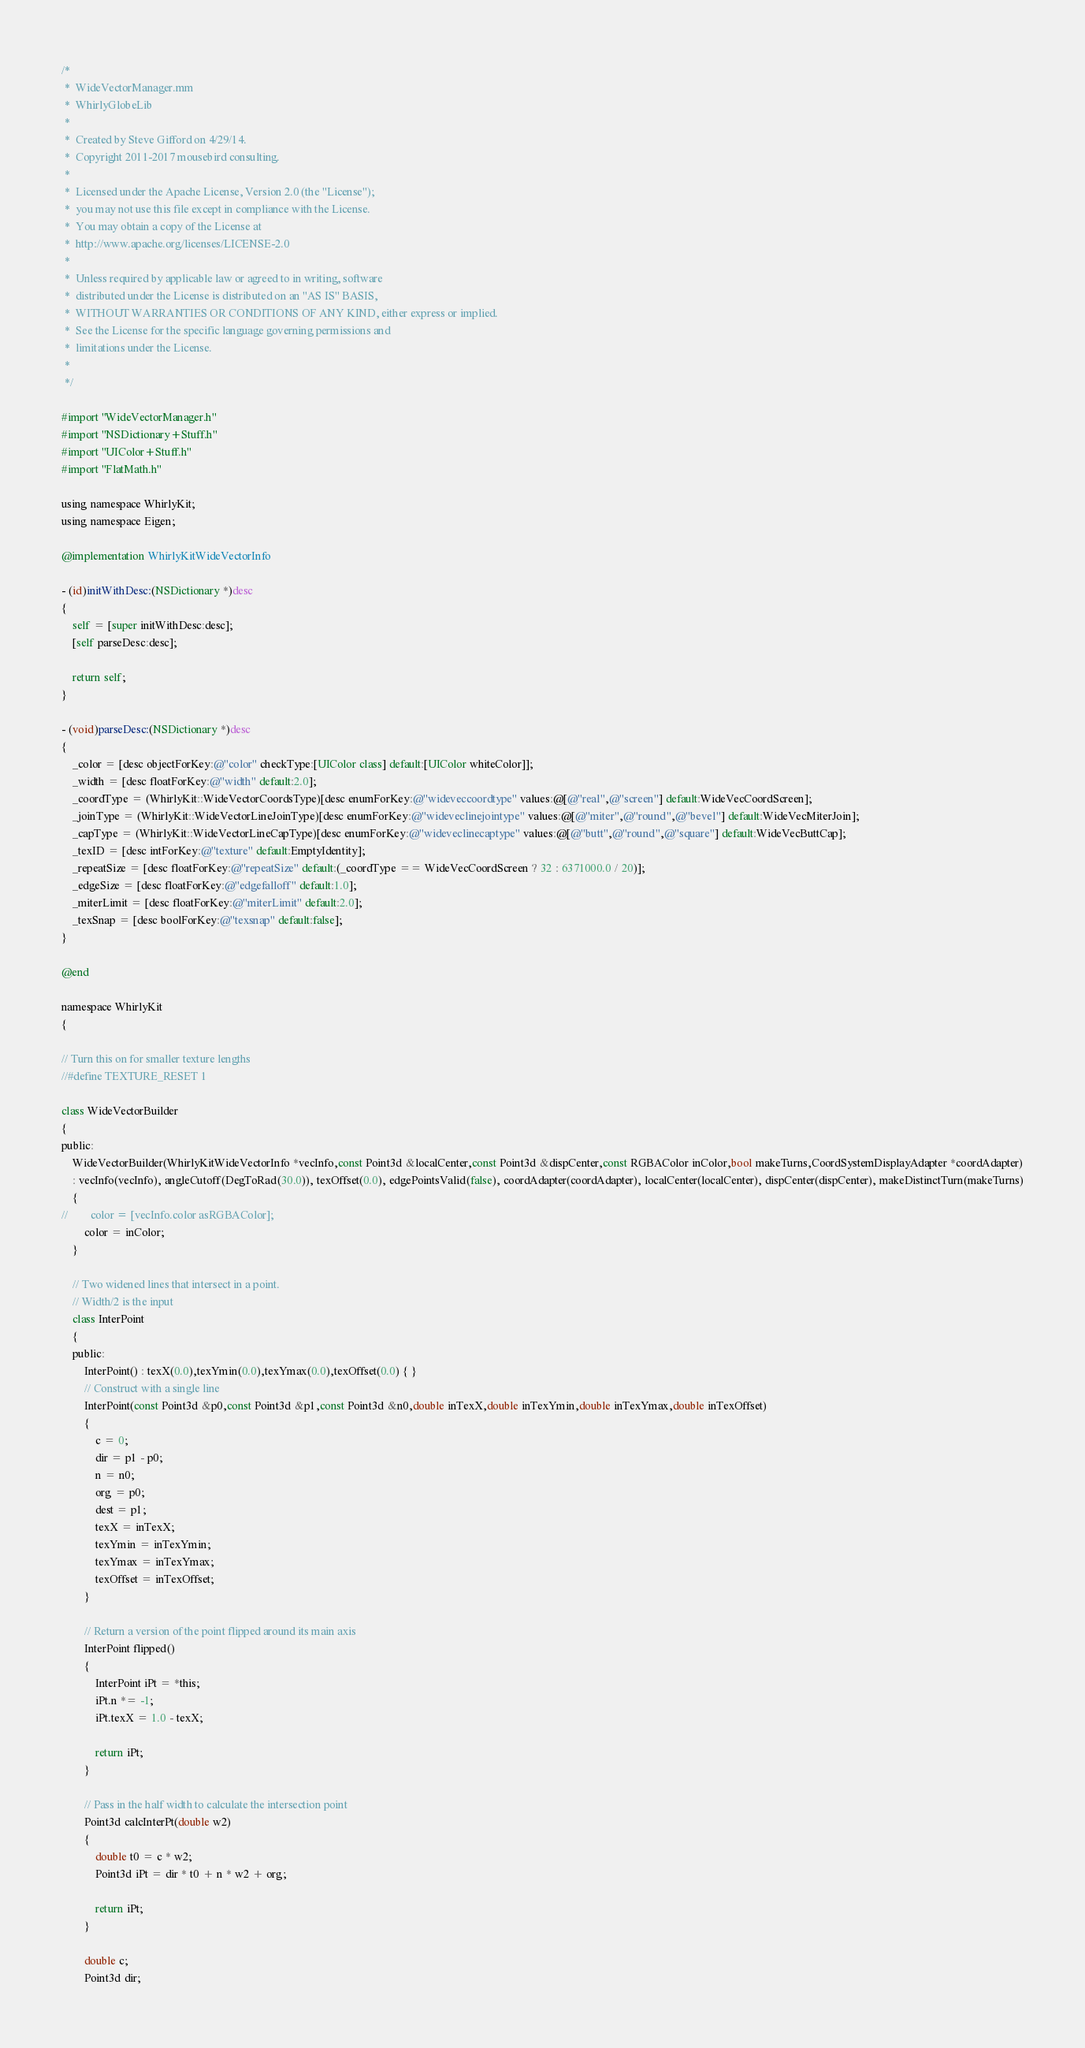<code> <loc_0><loc_0><loc_500><loc_500><_ObjectiveC_>/*
 *  WideVectorManager.mm
 *  WhirlyGlobeLib
 *
 *  Created by Steve Gifford on 4/29/14.
 *  Copyright 2011-2017 mousebird consulting.
 *
 *  Licensed under the Apache License, Version 2.0 (the "License");
 *  you may not use this file except in compliance with the License.
 *  You may obtain a copy of the License at
 *  http://www.apache.org/licenses/LICENSE-2.0
 *
 *  Unless required by applicable law or agreed to in writing, software
 *  distributed under the License is distributed on an "AS IS" BASIS,
 *  WITHOUT WARRANTIES OR CONDITIONS OF ANY KIND, either express or implied.
 *  See the License for the specific language governing permissions and
 *  limitations under the License.
 *
 */

#import "WideVectorManager.h"
#import "NSDictionary+Stuff.h"
#import "UIColor+Stuff.h"
#import "FlatMath.h"

using namespace WhirlyKit;
using namespace Eigen;

@implementation WhirlyKitWideVectorInfo

- (id)initWithDesc:(NSDictionary *)desc
{
    self = [super initWithDesc:desc];
    [self parseDesc:desc];
    
    return self;
}

- (void)parseDesc:(NSDictionary *)desc
{
    _color = [desc objectForKey:@"color" checkType:[UIColor class] default:[UIColor whiteColor]];
    _width = [desc floatForKey:@"width" default:2.0];
    _coordType = (WhirlyKit::WideVectorCoordsType)[desc enumForKey:@"wideveccoordtype" values:@[@"real",@"screen"] default:WideVecCoordScreen];
    _joinType = (WhirlyKit::WideVectorLineJoinType)[desc enumForKey:@"wideveclinejointype" values:@[@"miter",@"round",@"bevel"] default:WideVecMiterJoin];
    _capType = (WhirlyKit::WideVectorLineCapType)[desc enumForKey:@"wideveclinecaptype" values:@[@"butt",@"round",@"square"] default:WideVecButtCap];
    _texID = [desc intForKey:@"texture" default:EmptyIdentity];
    _repeatSize = [desc floatForKey:@"repeatSize" default:(_coordType == WideVecCoordScreen ? 32 : 6371000.0 / 20)];
    _edgeSize = [desc floatForKey:@"edgefalloff" default:1.0];
    _miterLimit = [desc floatForKey:@"miterLimit" default:2.0];
    _texSnap = [desc boolForKey:@"texsnap" default:false];
}

@end

namespace WhirlyKit
{

// Turn this on for smaller texture lengths
//#define TEXTURE_RESET 1

class WideVectorBuilder
{
public:
    WideVectorBuilder(WhirlyKitWideVectorInfo *vecInfo,const Point3d &localCenter,const Point3d &dispCenter,const RGBAColor inColor,bool makeTurns,CoordSystemDisplayAdapter *coordAdapter)
    : vecInfo(vecInfo), angleCutoff(DegToRad(30.0)), texOffset(0.0), edgePointsValid(false), coordAdapter(coordAdapter), localCenter(localCenter), dispCenter(dispCenter), makeDistinctTurn(makeTurns)
    {
//        color = [vecInfo.color asRGBAColor];
        color = inColor;
    }

    // Two widened lines that intersect in a point.
    // Width/2 is the input
    class InterPoint
    {
    public:
        InterPoint() : texX(0.0),texYmin(0.0),texYmax(0.0),texOffset(0.0) { }
        // Construct with a single line
        InterPoint(const Point3d &p0,const Point3d &p1,const Point3d &n0,double inTexX,double inTexYmin,double inTexYmax,double inTexOffset)
        {
            c = 0;
            dir = p1 - p0;
            n = n0;
            org = p0;
            dest = p1;
            texX = inTexX;
            texYmin = inTexYmin;
            texYmax = inTexYmax;
            texOffset = inTexOffset;
        }
        
        // Return a version of the point flipped around its main axis
        InterPoint flipped()
        {
            InterPoint iPt = *this;
            iPt.n *= -1;
            iPt.texX = 1.0 - texX;
            
            return iPt;
        }
        
        // Pass in the half width to calculate the intersection point
        Point3d calcInterPt(double w2)
        {
            double t0 = c * w2;
            Point3d iPt = dir * t0 + n * w2 + org;
            
            return iPt;
        }
        
        double c;
        Point3d dir;</code> 